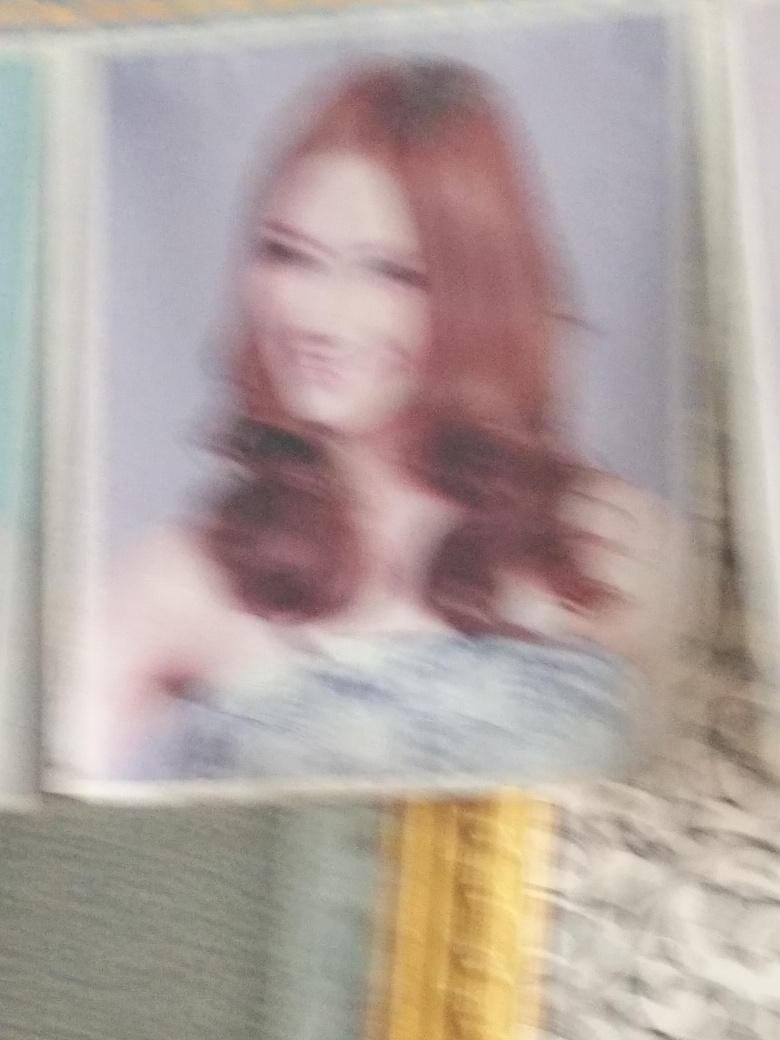If you were to give advice on how to improve a similar photo in the future, what would it be? To improve a similar photo, the focus should be on achieving clarity. This can be done by using a steady hand or a tripod to prevent camera shake, ensuring the camera lens is properly focused on the subject, and selecting an appropriate aperture and shutter speed for the lighting conditions. If the issue stems from a low-resolution capture, using a camera with a higher megapixel count or ensuring the digital image is not overly compressed would aid in enhancing the photo quality. 